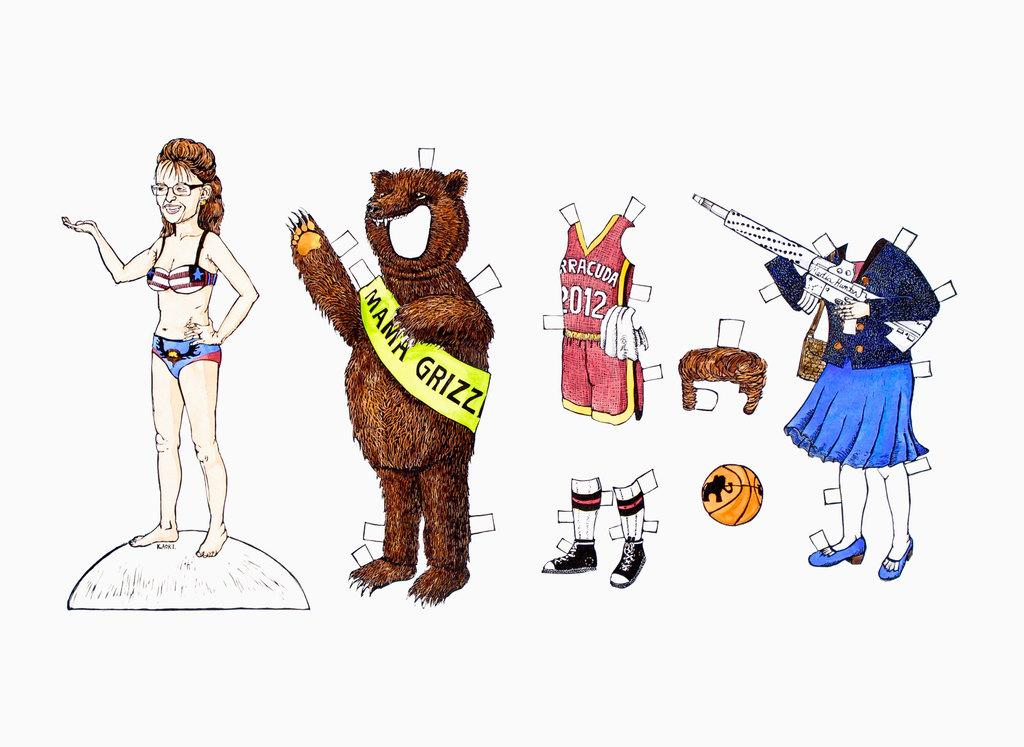What type of drawings can be seen in the image? There are drawings of costumes, a woman, and a ball in the image. Can you describe the woman in the drawing? There is a drawing of a woman in the image. What is the ball used for in the drawing? The drawing of a ball is present in the image, but its purpose is not specified. What is the color of the background in the image? The background of the image is white. How many mittens are visible in the image? There are no mittens present in the image. Is there a birthday celebration happening in the image? There is no indication of a birthday celebration in the image. 